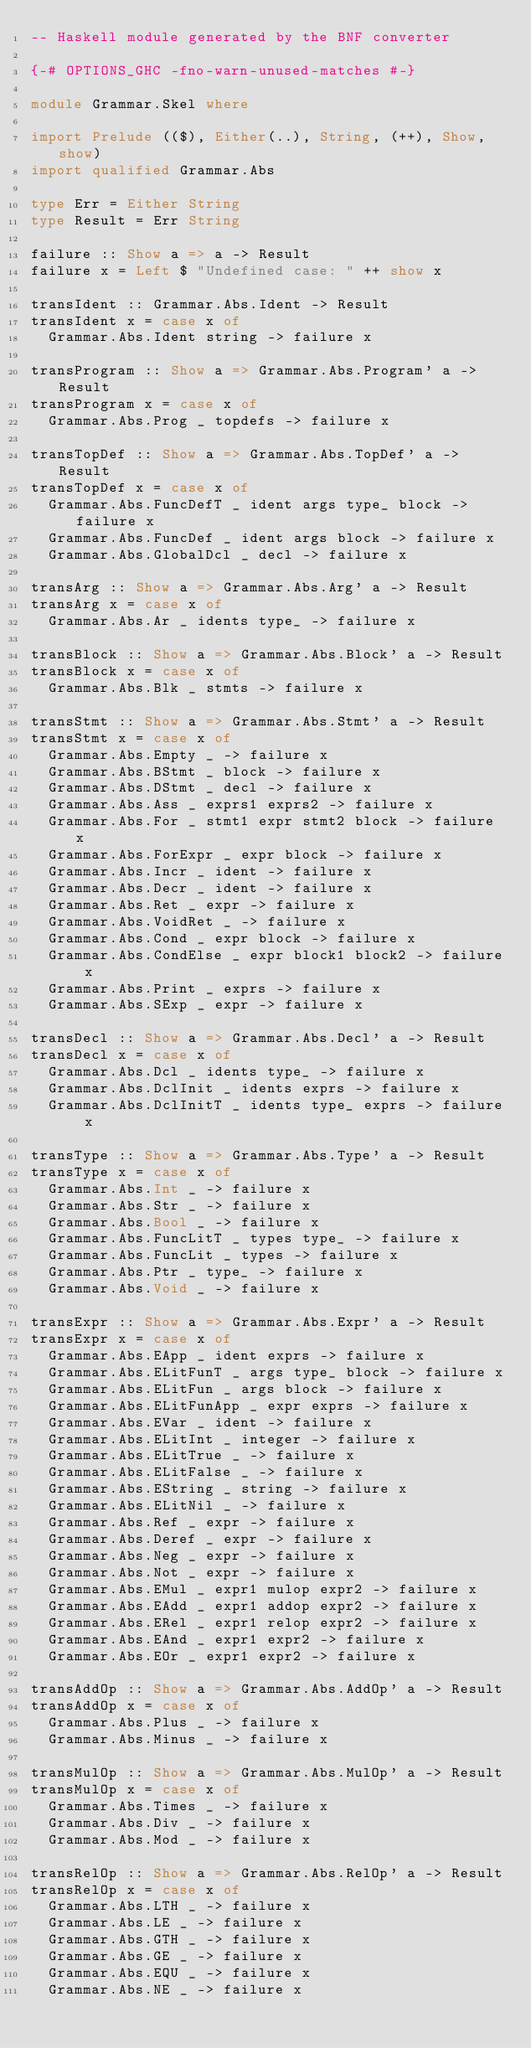Convert code to text. <code><loc_0><loc_0><loc_500><loc_500><_Haskell_>-- Haskell module generated by the BNF converter

{-# OPTIONS_GHC -fno-warn-unused-matches #-}

module Grammar.Skel where

import Prelude (($), Either(..), String, (++), Show, show)
import qualified Grammar.Abs

type Err = Either String
type Result = Err String

failure :: Show a => a -> Result
failure x = Left $ "Undefined case: " ++ show x

transIdent :: Grammar.Abs.Ident -> Result
transIdent x = case x of
  Grammar.Abs.Ident string -> failure x

transProgram :: Show a => Grammar.Abs.Program' a -> Result
transProgram x = case x of
  Grammar.Abs.Prog _ topdefs -> failure x

transTopDef :: Show a => Grammar.Abs.TopDef' a -> Result
transTopDef x = case x of
  Grammar.Abs.FuncDefT _ ident args type_ block -> failure x
  Grammar.Abs.FuncDef _ ident args block -> failure x
  Grammar.Abs.GlobalDcl _ decl -> failure x

transArg :: Show a => Grammar.Abs.Arg' a -> Result
transArg x = case x of
  Grammar.Abs.Ar _ idents type_ -> failure x

transBlock :: Show a => Grammar.Abs.Block' a -> Result
transBlock x = case x of
  Grammar.Abs.Blk _ stmts -> failure x

transStmt :: Show a => Grammar.Abs.Stmt' a -> Result
transStmt x = case x of
  Grammar.Abs.Empty _ -> failure x
  Grammar.Abs.BStmt _ block -> failure x
  Grammar.Abs.DStmt _ decl -> failure x
  Grammar.Abs.Ass _ exprs1 exprs2 -> failure x
  Grammar.Abs.For _ stmt1 expr stmt2 block -> failure x
  Grammar.Abs.ForExpr _ expr block -> failure x
  Grammar.Abs.Incr _ ident -> failure x
  Grammar.Abs.Decr _ ident -> failure x
  Grammar.Abs.Ret _ expr -> failure x
  Grammar.Abs.VoidRet _ -> failure x
  Grammar.Abs.Cond _ expr block -> failure x
  Grammar.Abs.CondElse _ expr block1 block2 -> failure x
  Grammar.Abs.Print _ exprs -> failure x
  Grammar.Abs.SExp _ expr -> failure x

transDecl :: Show a => Grammar.Abs.Decl' a -> Result
transDecl x = case x of
  Grammar.Abs.Dcl _ idents type_ -> failure x
  Grammar.Abs.DclInit _ idents exprs -> failure x
  Grammar.Abs.DclInitT _ idents type_ exprs -> failure x

transType :: Show a => Grammar.Abs.Type' a -> Result
transType x = case x of
  Grammar.Abs.Int _ -> failure x
  Grammar.Abs.Str _ -> failure x
  Grammar.Abs.Bool _ -> failure x
  Grammar.Abs.FuncLitT _ types type_ -> failure x
  Grammar.Abs.FuncLit _ types -> failure x
  Grammar.Abs.Ptr _ type_ -> failure x
  Grammar.Abs.Void _ -> failure x

transExpr :: Show a => Grammar.Abs.Expr' a -> Result
transExpr x = case x of
  Grammar.Abs.EApp _ ident exprs -> failure x
  Grammar.Abs.ELitFunT _ args type_ block -> failure x
  Grammar.Abs.ELitFun _ args block -> failure x
  Grammar.Abs.ELitFunApp _ expr exprs -> failure x
  Grammar.Abs.EVar _ ident -> failure x
  Grammar.Abs.ELitInt _ integer -> failure x
  Grammar.Abs.ELitTrue _ -> failure x
  Grammar.Abs.ELitFalse _ -> failure x
  Grammar.Abs.EString _ string -> failure x
  Grammar.Abs.ELitNil _ -> failure x
  Grammar.Abs.Ref _ expr -> failure x
  Grammar.Abs.Deref _ expr -> failure x
  Grammar.Abs.Neg _ expr -> failure x
  Grammar.Abs.Not _ expr -> failure x
  Grammar.Abs.EMul _ expr1 mulop expr2 -> failure x
  Grammar.Abs.EAdd _ expr1 addop expr2 -> failure x
  Grammar.Abs.ERel _ expr1 relop expr2 -> failure x
  Grammar.Abs.EAnd _ expr1 expr2 -> failure x
  Grammar.Abs.EOr _ expr1 expr2 -> failure x

transAddOp :: Show a => Grammar.Abs.AddOp' a -> Result
transAddOp x = case x of
  Grammar.Abs.Plus _ -> failure x
  Grammar.Abs.Minus _ -> failure x

transMulOp :: Show a => Grammar.Abs.MulOp' a -> Result
transMulOp x = case x of
  Grammar.Abs.Times _ -> failure x
  Grammar.Abs.Div _ -> failure x
  Grammar.Abs.Mod _ -> failure x

transRelOp :: Show a => Grammar.Abs.RelOp' a -> Result
transRelOp x = case x of
  Grammar.Abs.LTH _ -> failure x
  Grammar.Abs.LE _ -> failure x
  Grammar.Abs.GTH _ -> failure x
  Grammar.Abs.GE _ -> failure x
  Grammar.Abs.EQU _ -> failure x
  Grammar.Abs.NE _ -> failure x
</code> 